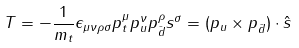Convert formula to latex. <formula><loc_0><loc_0><loc_500><loc_500>T = - \frac { 1 } { m _ { t } } \epsilon _ { \mu \nu \rho \sigma } p _ { t } ^ { \mu } p _ { u } ^ { \nu } p _ { \bar { d } } ^ { \rho } s ^ { \sigma } = ( p _ { u } \times p _ { \bar { d } } ) \cdot \hat { s }</formula> 